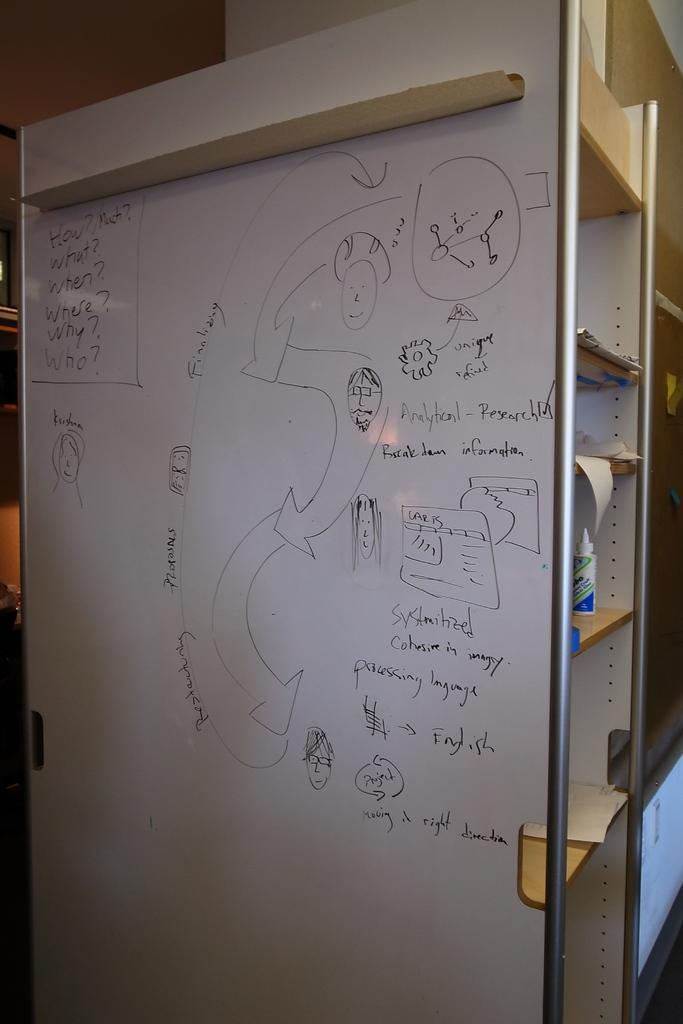<image>
Share a concise interpretation of the image provided. A map with different area on a white board along with how much what when why and where. 